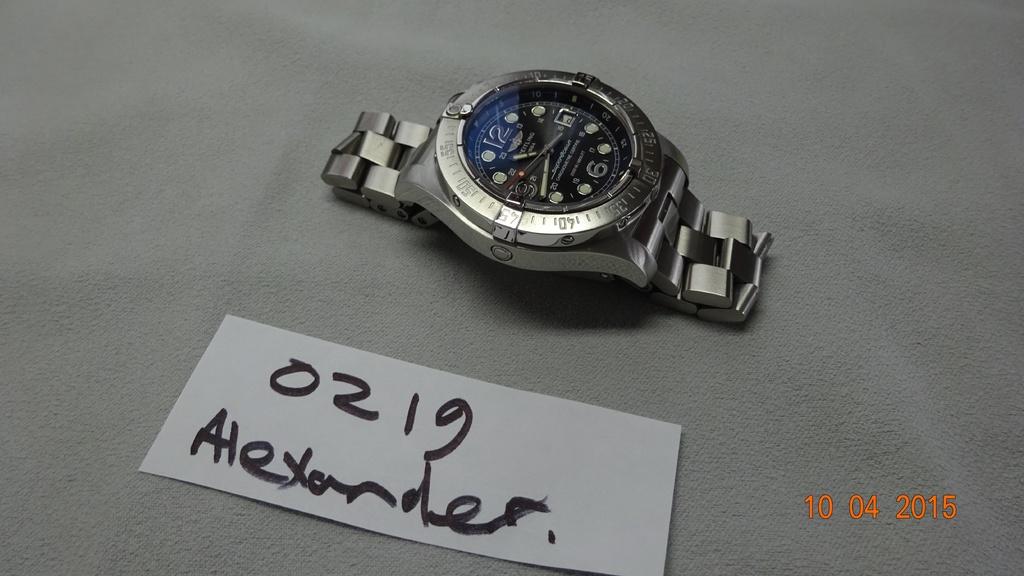What brand of watch is this?
Offer a terse response. Unanswerable. What number is shown?
Keep it short and to the point. 0219. 